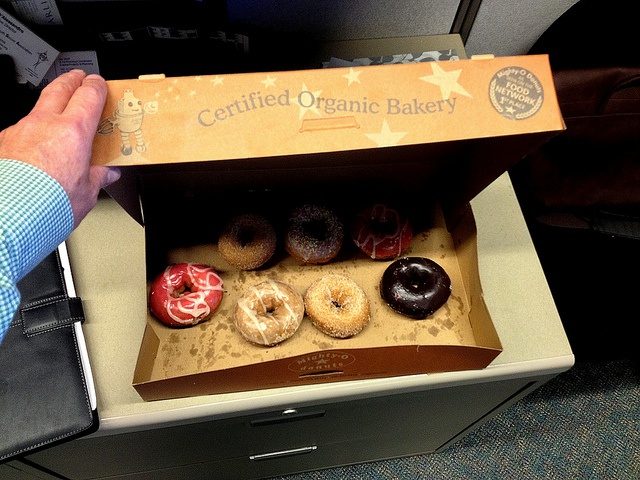Describe the objects in this image and their specific colors. I can see people in black, salmon, lightblue, and ivory tones, donut in black, brown, salmon, and maroon tones, donut in black, tan, and olive tones, donut in black, maroon, and brown tones, and donut in black, gray, and darkgray tones in this image. 